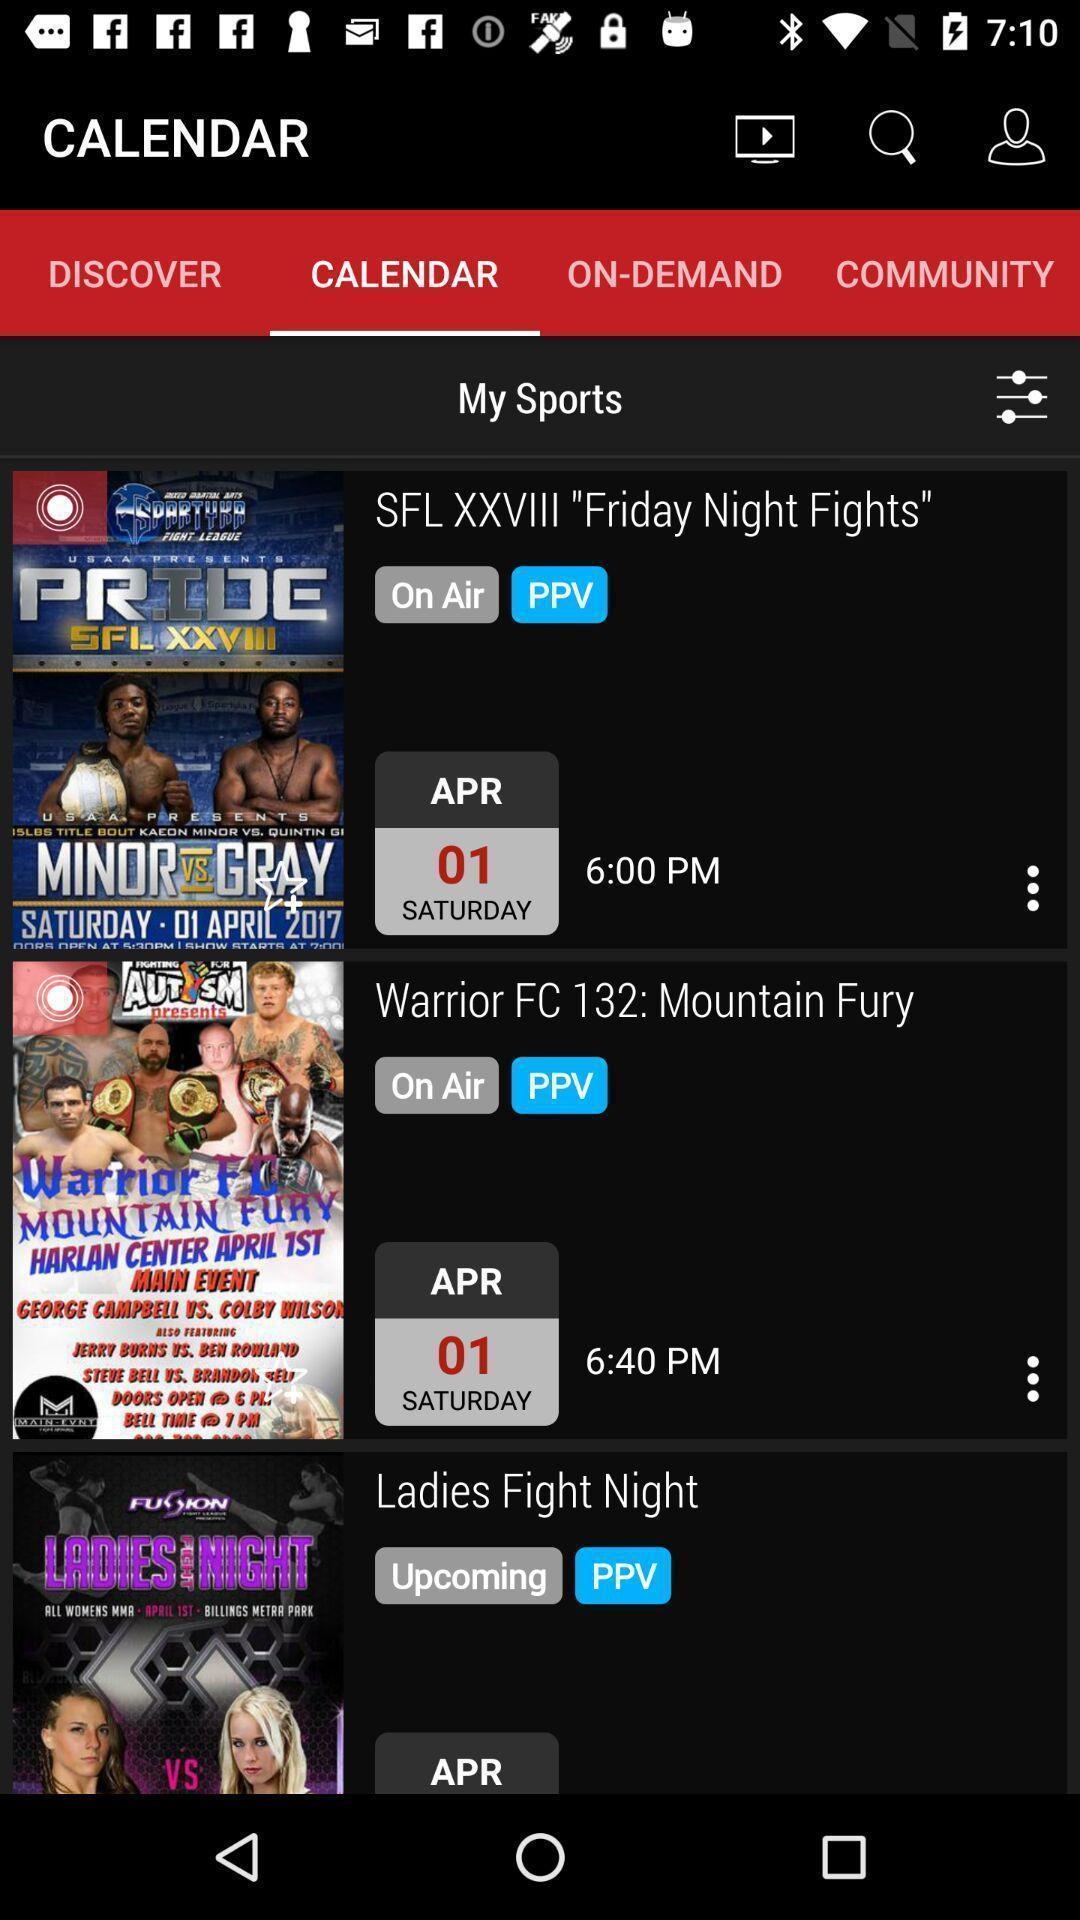What details can you identify in this image? Page showing shows and movies with multiple icons in app. 